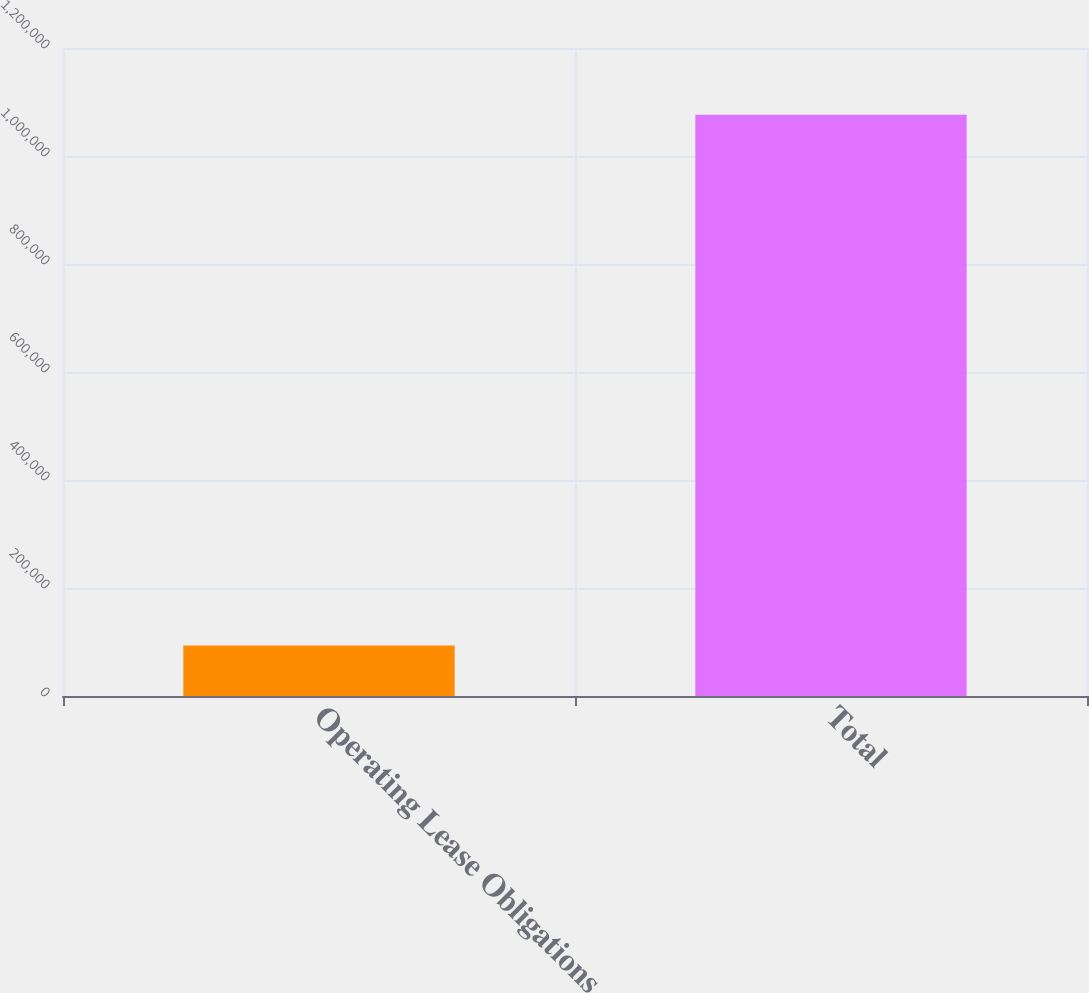Convert chart to OTSL. <chart><loc_0><loc_0><loc_500><loc_500><bar_chart><fcel>Operating Lease Obligations<fcel>Total<nl><fcel>93692<fcel>1.07619e+06<nl></chart> 